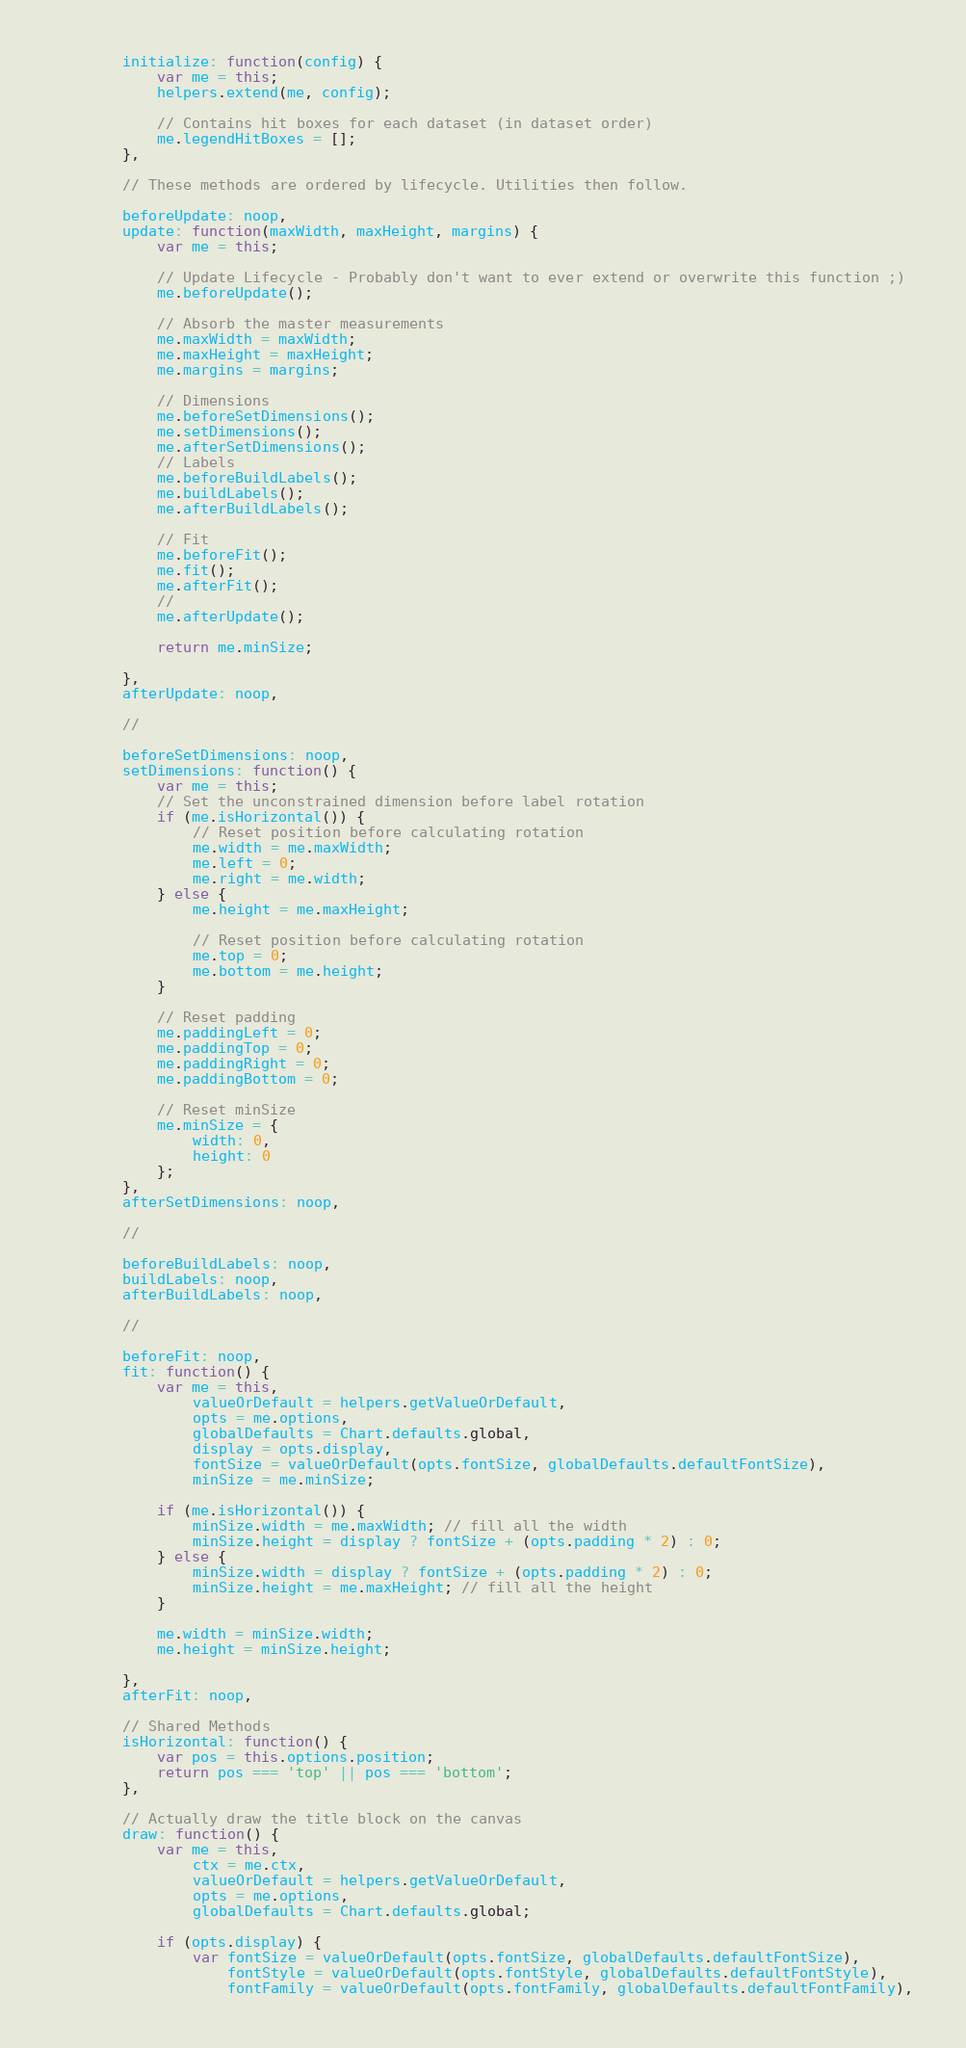<code> <loc_0><loc_0><loc_500><loc_500><_JavaScript_>		initialize: function(config) {
			var me = this;
			helpers.extend(me, config);

			// Contains hit boxes for each dataset (in dataset order)
			me.legendHitBoxes = [];
		},

		// These methods are ordered by lifecycle. Utilities then follow.

		beforeUpdate: noop,
		update: function(maxWidth, maxHeight, margins) {
			var me = this;

			// Update Lifecycle - Probably don't want to ever extend or overwrite this function ;)
			me.beforeUpdate();

			// Absorb the master measurements
			me.maxWidth = maxWidth;
			me.maxHeight = maxHeight;
			me.margins = margins;

			// Dimensions
			me.beforeSetDimensions();
			me.setDimensions();
			me.afterSetDimensions();
			// Labels
			me.beforeBuildLabels();
			me.buildLabels();
			me.afterBuildLabels();

			// Fit
			me.beforeFit();
			me.fit();
			me.afterFit();
			//
			me.afterUpdate();

			return me.minSize;

		},
		afterUpdate: noop,

		//

		beforeSetDimensions: noop,
		setDimensions: function() {
			var me = this;
			// Set the unconstrained dimension before label rotation
			if (me.isHorizontal()) {
				// Reset position before calculating rotation
				me.width = me.maxWidth;
				me.left = 0;
				me.right = me.width;
			} else {
				me.height = me.maxHeight;

				// Reset position before calculating rotation
				me.top = 0;
				me.bottom = me.height;
			}

			// Reset padding
			me.paddingLeft = 0;
			me.paddingTop = 0;
			me.paddingRight = 0;
			me.paddingBottom = 0;

			// Reset minSize
			me.minSize = {
				width: 0,
				height: 0
			};
		},
		afterSetDimensions: noop,

		//

		beforeBuildLabels: noop,
		buildLabels: noop,
		afterBuildLabels: noop,

		//

		beforeFit: noop,
		fit: function() {
			var me = this,
				valueOrDefault = helpers.getValueOrDefault,
				opts = me.options,
				globalDefaults = Chart.defaults.global,
				display = opts.display,
				fontSize = valueOrDefault(opts.fontSize, globalDefaults.defaultFontSize),
				minSize = me.minSize;

			if (me.isHorizontal()) {
				minSize.width = me.maxWidth; // fill all the width
				minSize.height = display ? fontSize + (opts.padding * 2) : 0;
			} else {
				minSize.width = display ? fontSize + (opts.padding * 2) : 0;
				minSize.height = me.maxHeight; // fill all the height
			}

			me.width = minSize.width;
			me.height = minSize.height;

		},
		afterFit: noop,

		// Shared Methods
		isHorizontal: function() {
			var pos = this.options.position;
			return pos === 'top' || pos === 'bottom';
		},

		// Actually draw the title block on the canvas
		draw: function() {
			var me = this,
				ctx = me.ctx,
				valueOrDefault = helpers.getValueOrDefault,
				opts = me.options,
				globalDefaults = Chart.defaults.global;

			if (opts.display) {
				var fontSize = valueOrDefault(opts.fontSize, globalDefaults.defaultFontSize),
					fontStyle = valueOrDefault(opts.fontStyle, globalDefaults.defaultFontStyle),
					fontFamily = valueOrDefault(opts.fontFamily, globalDefaults.defaultFontFamily),</code> 